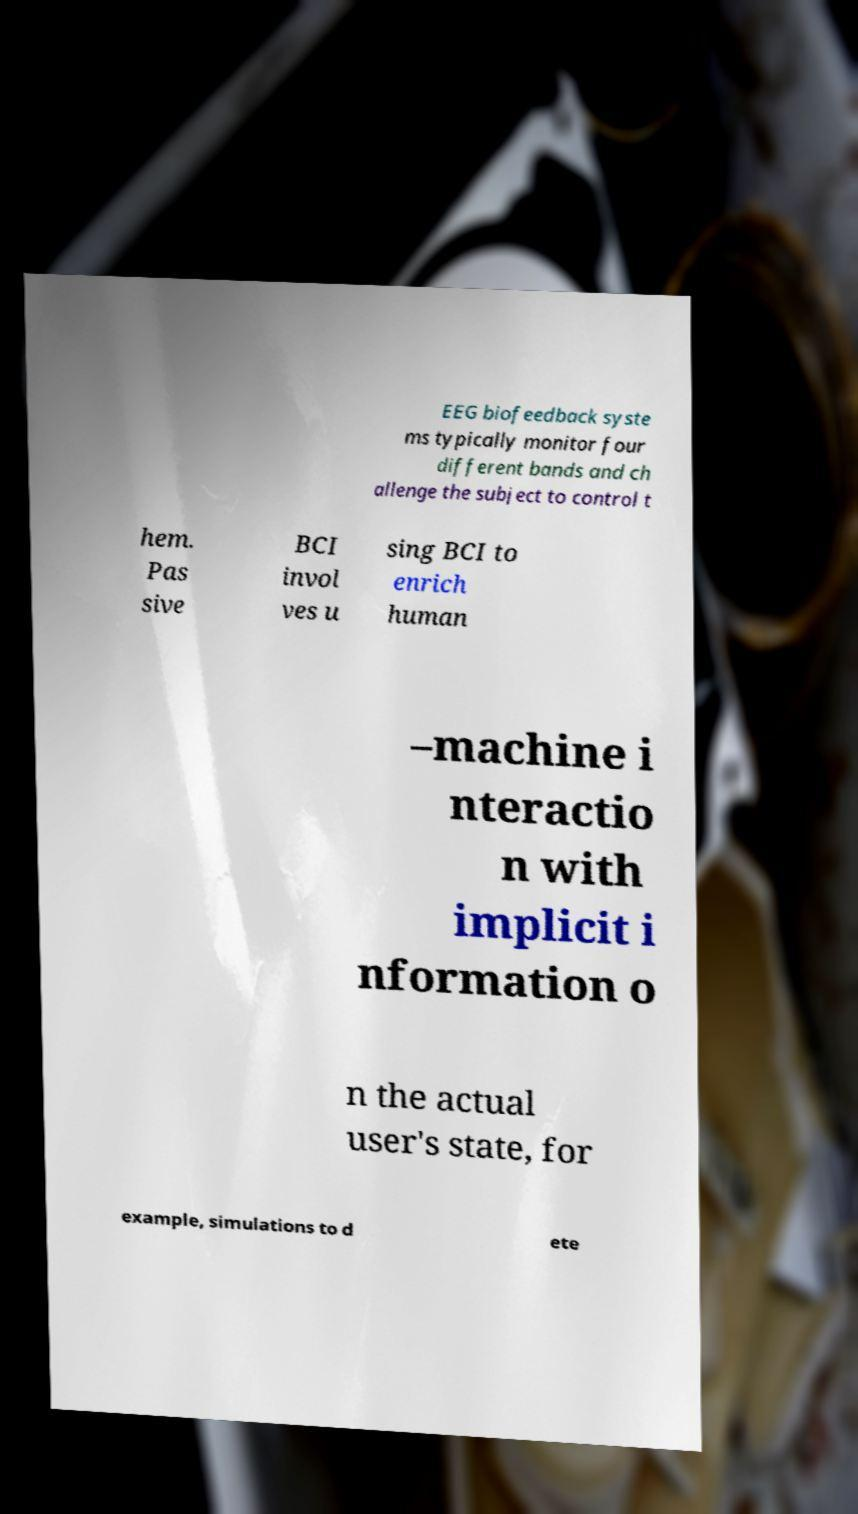For documentation purposes, I need the text within this image transcribed. Could you provide that? EEG biofeedback syste ms typically monitor four different bands and ch allenge the subject to control t hem. Pas sive BCI invol ves u sing BCI to enrich human –machine i nteractio n with implicit i nformation o n the actual user's state, for example, simulations to d ete 